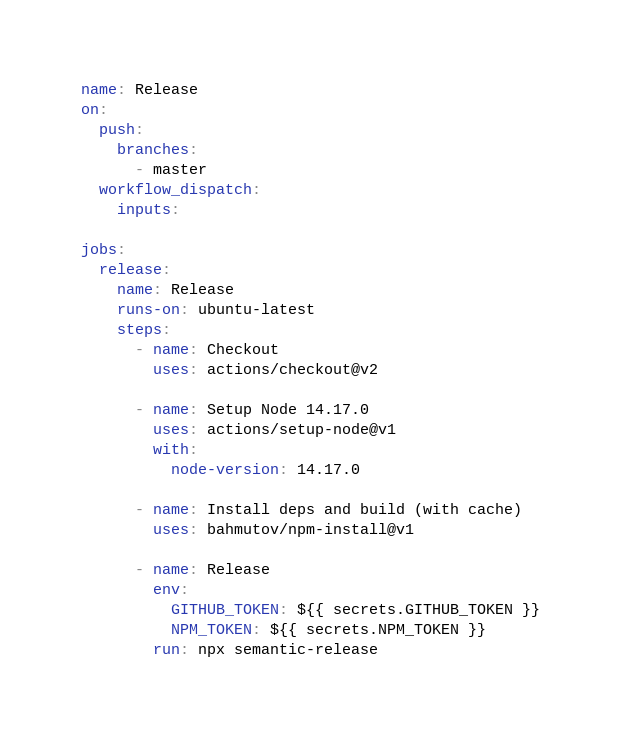Convert code to text. <code><loc_0><loc_0><loc_500><loc_500><_YAML_>name: Release
on:
  push:
    branches:
      - master
  workflow_dispatch:
    inputs:

jobs:
  release:
    name: Release
    runs-on: ubuntu-latest
    steps:
      - name: Checkout
        uses: actions/checkout@v2

      - name: Setup Node 14.17.0
        uses: actions/setup-node@v1
        with:
          node-version: 14.17.0

      - name: Install deps and build (with cache)
        uses: bahmutov/npm-install@v1

      - name: Release
        env:
          GITHUB_TOKEN: ${{ secrets.GITHUB_TOKEN }}
          NPM_TOKEN: ${{ secrets.NPM_TOKEN }}
        run: npx semantic-release
</code> 